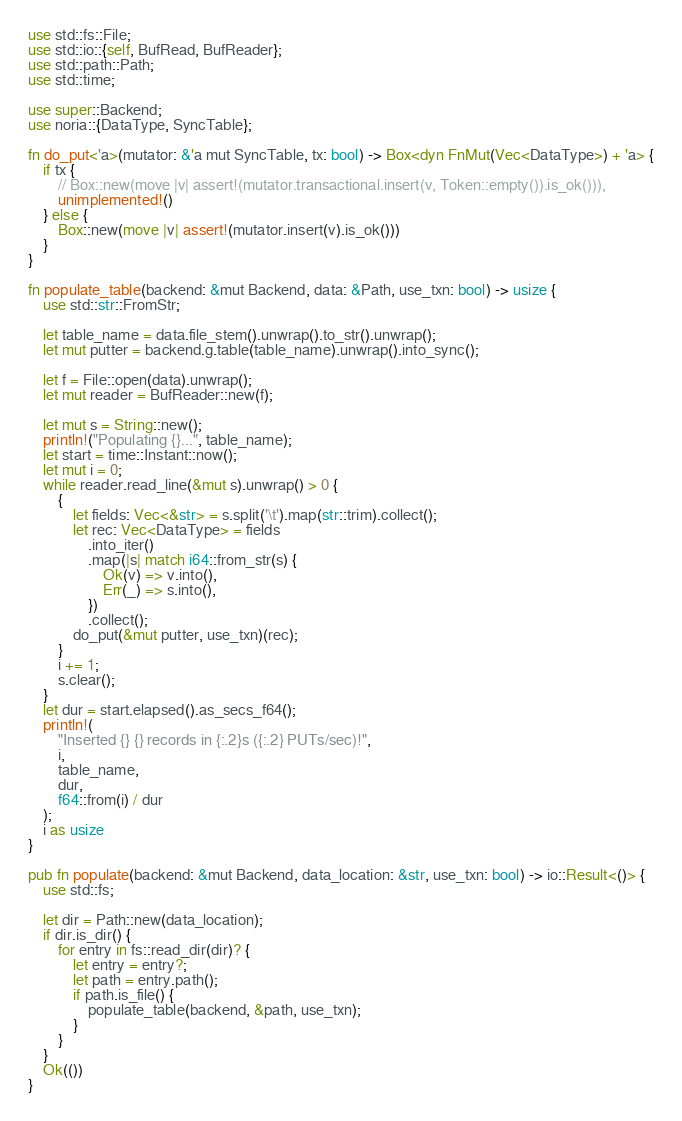<code> <loc_0><loc_0><loc_500><loc_500><_Rust_>use std::fs::File;
use std::io::{self, BufRead, BufReader};
use std::path::Path;
use std::time;

use super::Backend;
use noria::{DataType, SyncTable};

fn do_put<'a>(mutator: &'a mut SyncTable, tx: bool) -> Box<dyn FnMut(Vec<DataType>) + 'a> {
    if tx {
        // Box::new(move |v| assert!(mutator.transactional.insert(v, Token::empty()).is_ok())),
        unimplemented!()
    } else {
        Box::new(move |v| assert!(mutator.insert(v).is_ok()))
    }
}

fn populate_table(backend: &mut Backend, data: &Path, use_txn: bool) -> usize {
    use std::str::FromStr;

    let table_name = data.file_stem().unwrap().to_str().unwrap();
    let mut putter = backend.g.table(table_name).unwrap().into_sync();

    let f = File::open(data).unwrap();
    let mut reader = BufReader::new(f);

    let mut s = String::new();
    println!("Populating {}...", table_name);
    let start = time::Instant::now();
    let mut i = 0;
    while reader.read_line(&mut s).unwrap() > 0 {
        {
            let fields: Vec<&str> = s.split('\t').map(str::trim).collect();
            let rec: Vec<DataType> = fields
                .into_iter()
                .map(|s| match i64::from_str(s) {
                    Ok(v) => v.into(),
                    Err(_) => s.into(),
                })
                .collect();
            do_put(&mut putter, use_txn)(rec);
        }
        i += 1;
        s.clear();
    }
    let dur = start.elapsed().as_secs_f64();
    println!(
        "Inserted {} {} records in {:.2}s ({:.2} PUTs/sec)!",
        i,
        table_name,
        dur,
        f64::from(i) / dur
    );
    i as usize
}

pub fn populate(backend: &mut Backend, data_location: &str, use_txn: bool) -> io::Result<()> {
    use std::fs;

    let dir = Path::new(data_location);
    if dir.is_dir() {
        for entry in fs::read_dir(dir)? {
            let entry = entry?;
            let path = entry.path();
            if path.is_file() {
                populate_table(backend, &path, use_txn);
            }
        }
    }
    Ok(())
}
</code> 